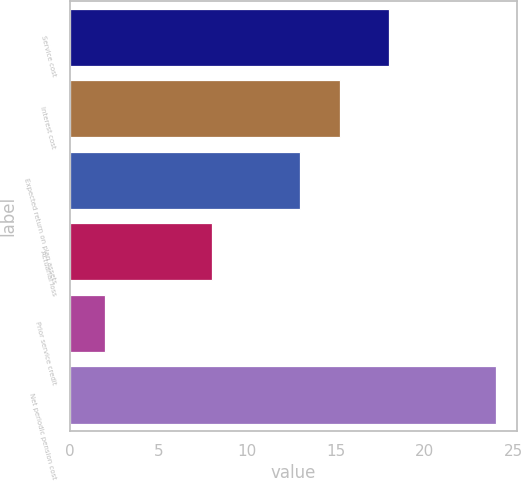Convert chart. <chart><loc_0><loc_0><loc_500><loc_500><bar_chart><fcel>Service cost<fcel>Interest cost<fcel>Expected return on plan assets<fcel>Actuarial loss<fcel>Prior service credit<fcel>Net periodic pension cost<nl><fcel>18<fcel>15.2<fcel>13<fcel>8<fcel>2<fcel>24<nl></chart> 